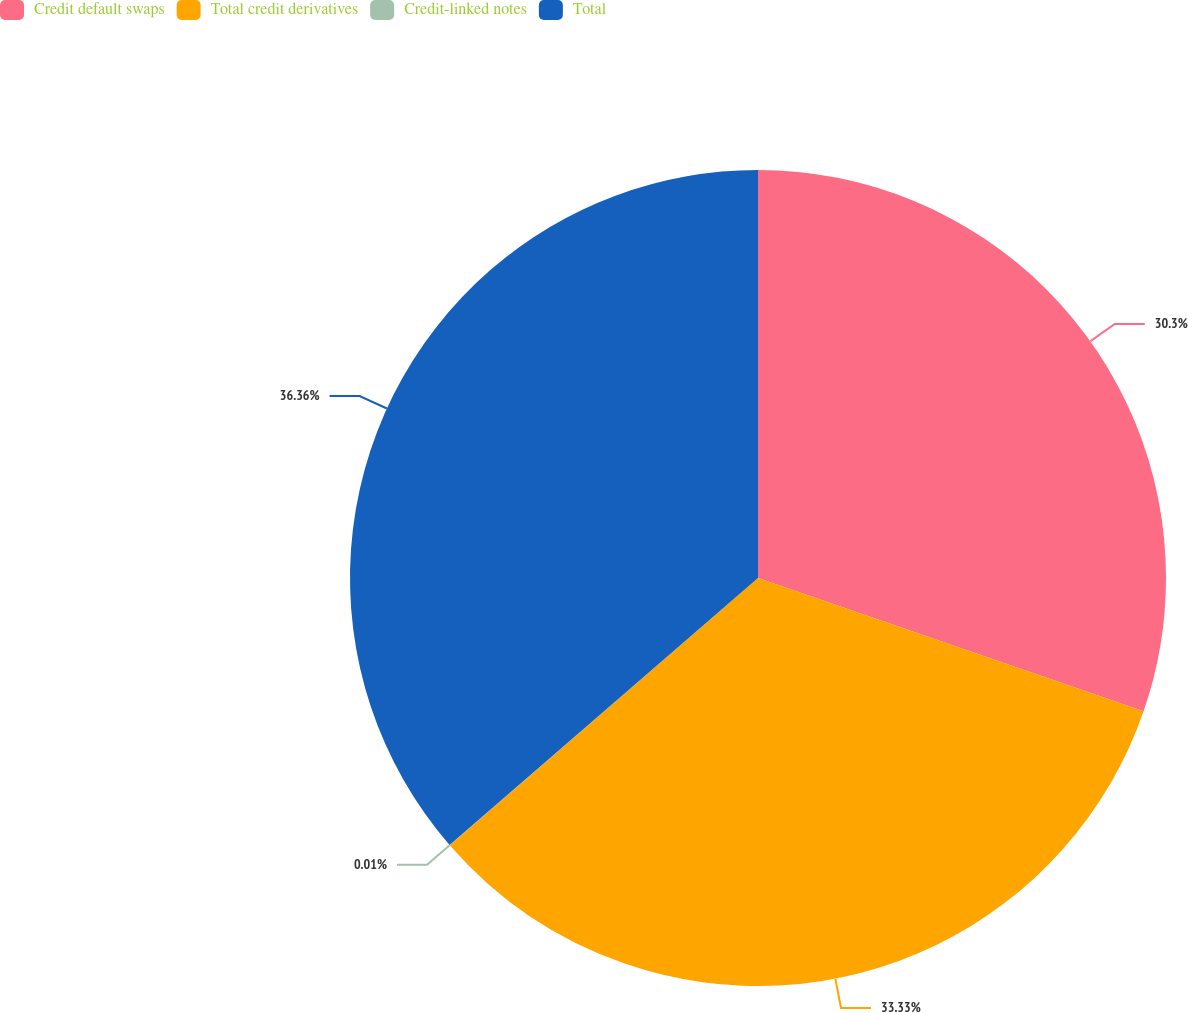Convert chart. <chart><loc_0><loc_0><loc_500><loc_500><pie_chart><fcel>Credit default swaps<fcel>Total credit derivatives<fcel>Credit-linked notes<fcel>Total<nl><fcel>30.3%<fcel>33.33%<fcel>0.01%<fcel>36.36%<nl></chart> 